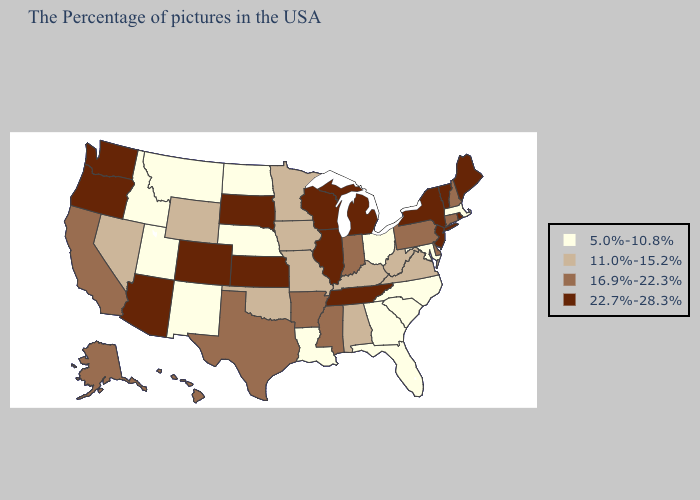Which states have the highest value in the USA?
Give a very brief answer. Maine, Rhode Island, Vermont, New York, New Jersey, Michigan, Tennessee, Wisconsin, Illinois, Kansas, South Dakota, Colorado, Arizona, Washington, Oregon. Does Ohio have the highest value in the USA?
Short answer required. No. Does the map have missing data?
Give a very brief answer. No. Does New York have the lowest value in the Northeast?
Quick response, please. No. What is the highest value in the Northeast ?
Keep it brief. 22.7%-28.3%. Name the states that have a value in the range 16.9%-22.3%?
Be succinct. New Hampshire, Connecticut, Delaware, Pennsylvania, Indiana, Mississippi, Arkansas, Texas, California, Alaska, Hawaii. Name the states that have a value in the range 22.7%-28.3%?
Keep it brief. Maine, Rhode Island, Vermont, New York, New Jersey, Michigan, Tennessee, Wisconsin, Illinois, Kansas, South Dakota, Colorado, Arizona, Washington, Oregon. What is the value of New York?
Answer briefly. 22.7%-28.3%. Name the states that have a value in the range 16.9%-22.3%?
Give a very brief answer. New Hampshire, Connecticut, Delaware, Pennsylvania, Indiana, Mississippi, Arkansas, Texas, California, Alaska, Hawaii. Does the map have missing data?
Give a very brief answer. No. What is the highest value in the USA?
Quick response, please. 22.7%-28.3%. Does the map have missing data?
Quick response, please. No. Does Arizona have a higher value than Maine?
Be succinct. No. Is the legend a continuous bar?
Answer briefly. No. What is the lowest value in states that border Nevada?
Keep it brief. 5.0%-10.8%. 